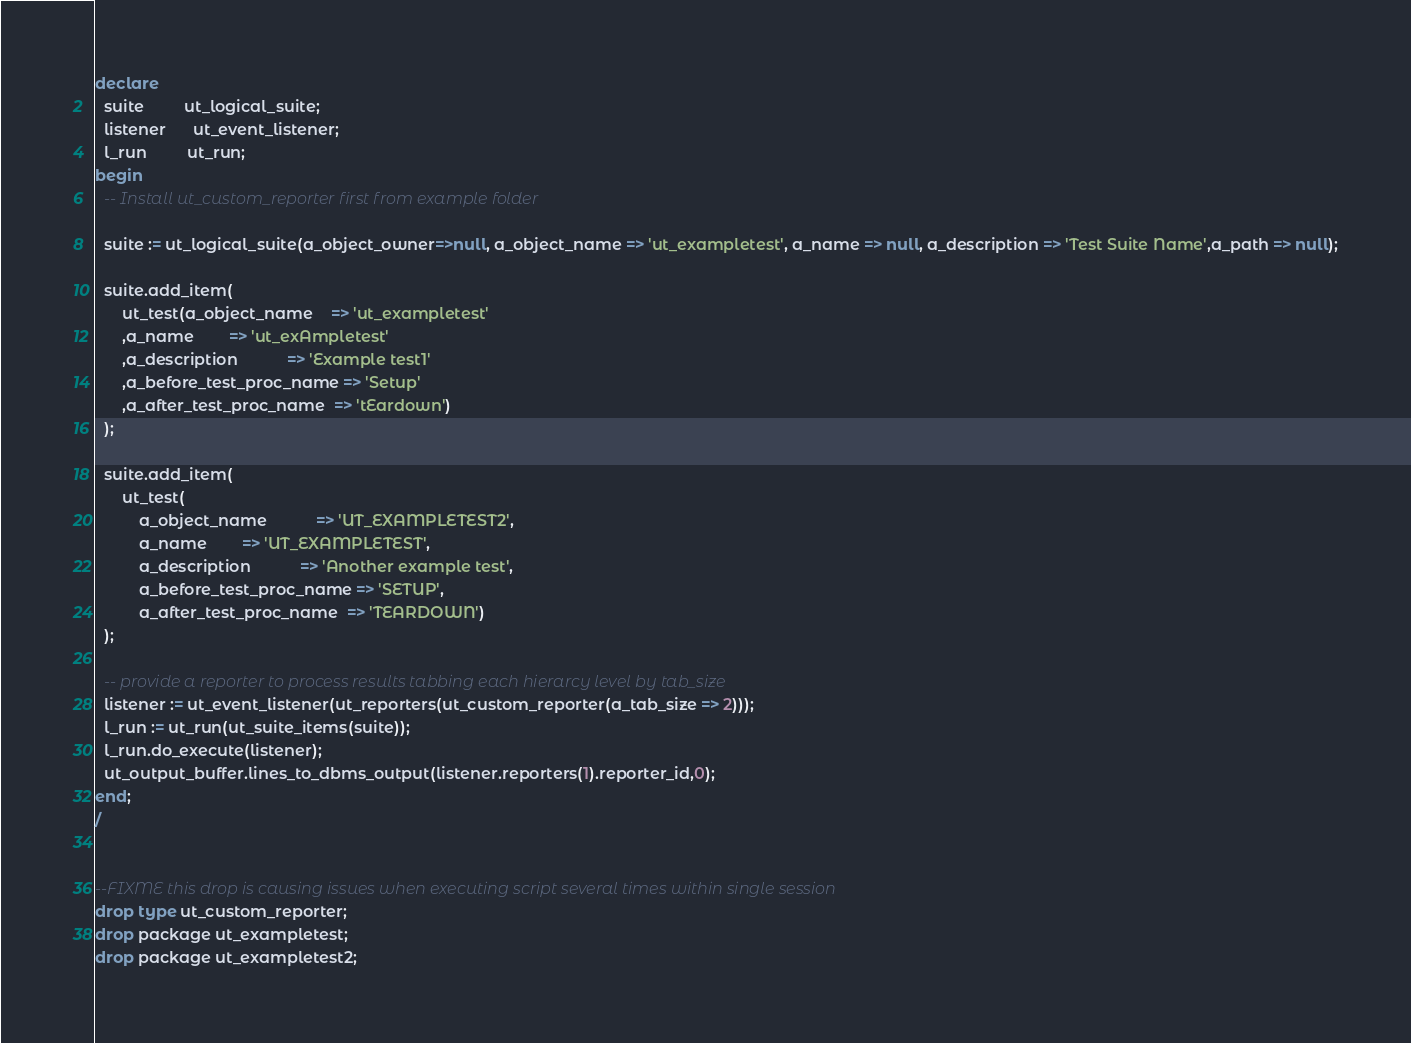<code> <loc_0><loc_0><loc_500><loc_500><_SQL_>declare
  suite         ut_logical_suite;
  listener      ut_event_listener;
  l_run         ut_run;
begin
  -- Install ut_custom_reporter first from example folder

  suite := ut_logical_suite(a_object_owner=>null, a_object_name => 'ut_exampletest', a_name => null, a_description => 'Test Suite Name',a_path => null);

  suite.add_item(
      ut_test(a_object_name    => 'ut_exampletest'
      ,a_name        => 'ut_exAmpletest'
      ,a_description           => 'Example test1'
      ,a_before_test_proc_name => 'Setup'
      ,a_after_test_proc_name  => 'tEardown')
  );

  suite.add_item(
      ut_test(
          a_object_name           => 'UT_EXAMPLETEST2',
          a_name        => 'UT_EXAMPLETEST',
          a_description           => 'Another example test',
          a_before_test_proc_name => 'SETUP',
          a_after_test_proc_name  => 'TEARDOWN')
  );

  -- provide a reporter to process results tabbing each hierarcy level by tab_size
  listener := ut_event_listener(ut_reporters(ut_custom_reporter(a_tab_size => 2)));
  l_run := ut_run(ut_suite_items(suite));
  l_run.do_execute(listener);
  ut_output_buffer.lines_to_dbms_output(listener.reporters(1).reporter_id,0);
end;
/


--FIXME this drop is causing issues when executing script several times within single session
drop type ut_custom_reporter;
drop package ut_exampletest;
drop package ut_exampletest2;
</code> 